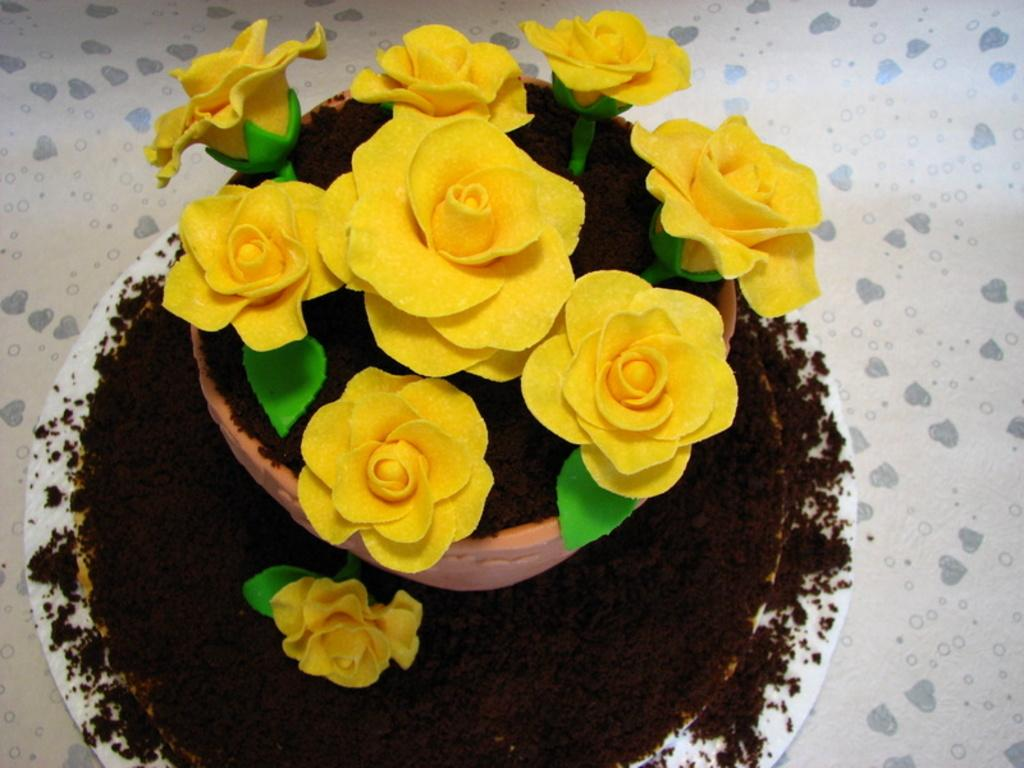What object is present on the surface in the image? There is a white plate on the surface in the image. What is on the plate? There is soil and a flower on the plate. Are there any other plants visible on the plate? Yes, there is a pot with flowers on the plate. How does the person in the image use a comb to sort the flowers? There is no person present in the image, and no comb or sorting activity is depicted. 